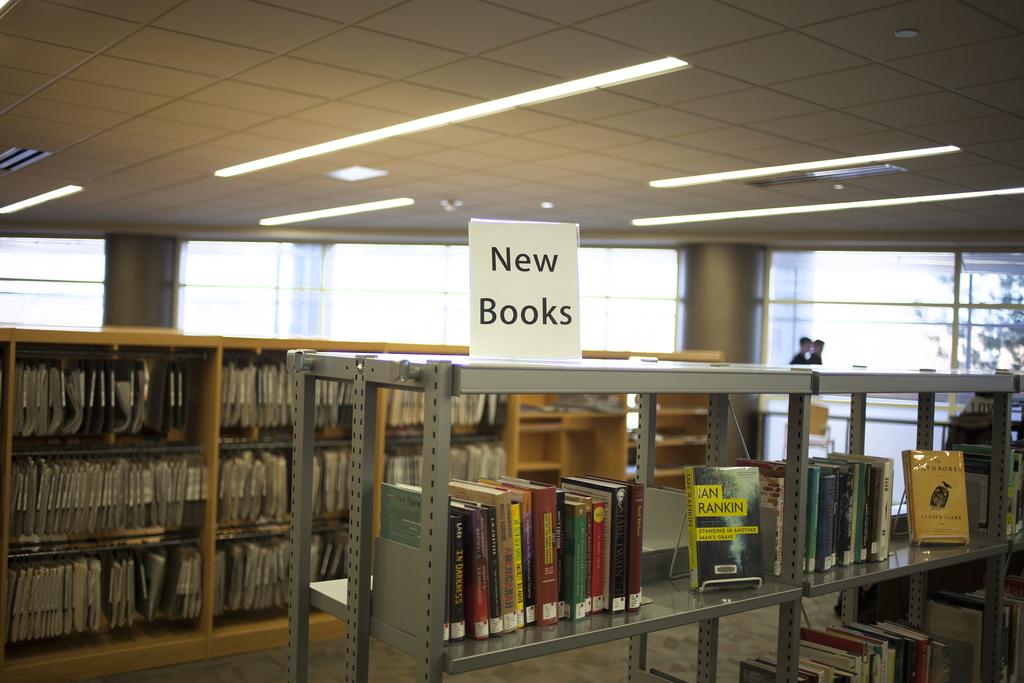What would you choose in a library of your wanted to read something you had never read before?
Offer a very short reply. New books. What does the sign on the shelf say?
Make the answer very short. New books. 